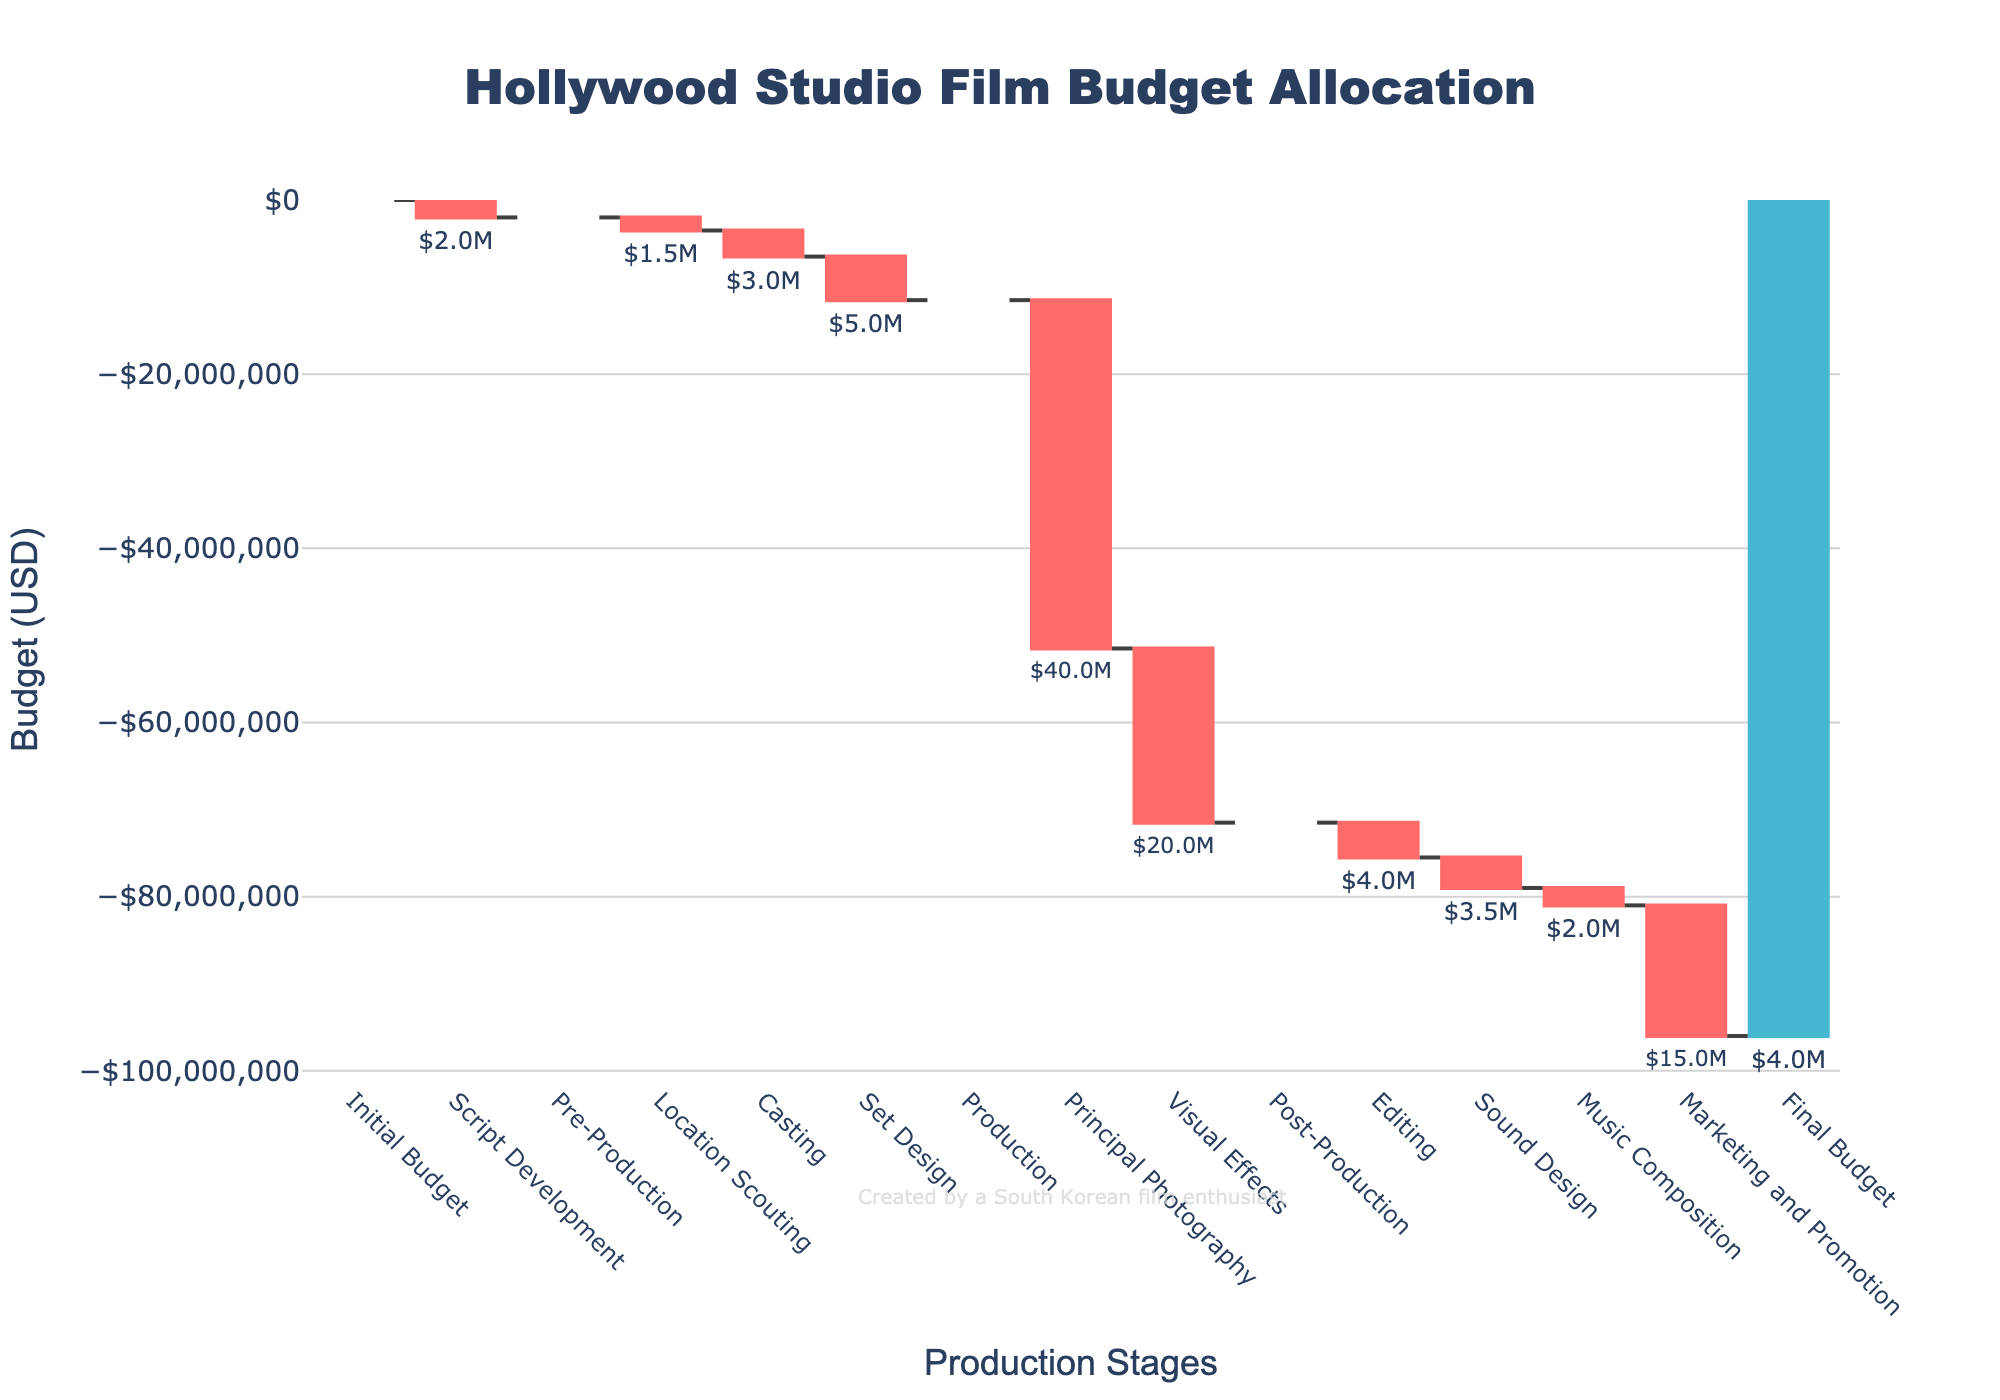What's the title of the figure? The title is usually found at the top of the figure and summarizes what the chart is about. Here, it appears as "Hollywood Studio Film Budget Allocation".
Answer: Hollywood Studio Film Budget Allocation Which category incurred the highest cost during production? The largest negative value (decrease) within the "Production" stage is the cost for Principal Photography, which is $40M.
Answer: Principal Photography What is the final budget remaining after all the expenses? The final figure shown as a "total" value in the chart is $4,000,000. This is indicated as the "Final Budget".
Answer: $4,000,000 What is the total cost spent on Pre-Production? Adding up all negative values within the Pre-Production stage: Location Scouting (-1.5M), Casting (-3M), and Set Design (-5M), the total is $9.5M.
Answer: - $9,500,000 How much was spent on Visual Effects? Look for the category "Visual Effects" and see its corresponding value, which is -$20M.
Answer: $20,000,000 How are the increases and decreases in the budget differentiated? Increases are shown in a different color compared to decreases. The figure uses different colors to indicate positive and negative changes; in this case, decreases are shown in red and increases in green.
Answer: Colors indicate increases and decreases Which two categories in Post-Production had roughly the same cost? By comparing the negative values under Post-Production, both Editing (-$4M) and Sound Design (-$3.5M) are quite close in cost.
Answer: Editing and Sound Design What is the script development cost relative to the initial budget? Since Script Development shows a decrease of $2M from the initial budget of $100M, it is -$2M.
Answer: $2,000,000 What is the total amount allocated to Post-Production? Summing up the costs: Editing (-$4M), Sound Design (-$3.5M), and Music Composition (-$2M), the total is -$9.5M.
Answer: $9,500,000 Compare the cost of Marketing and Promotion to Principal Photography. Which is greater? Principal Photography costs $40M and Marketing and Promotion costs $15M, so Principal Photography is greater at $40M.
Answer: Principal Photography 